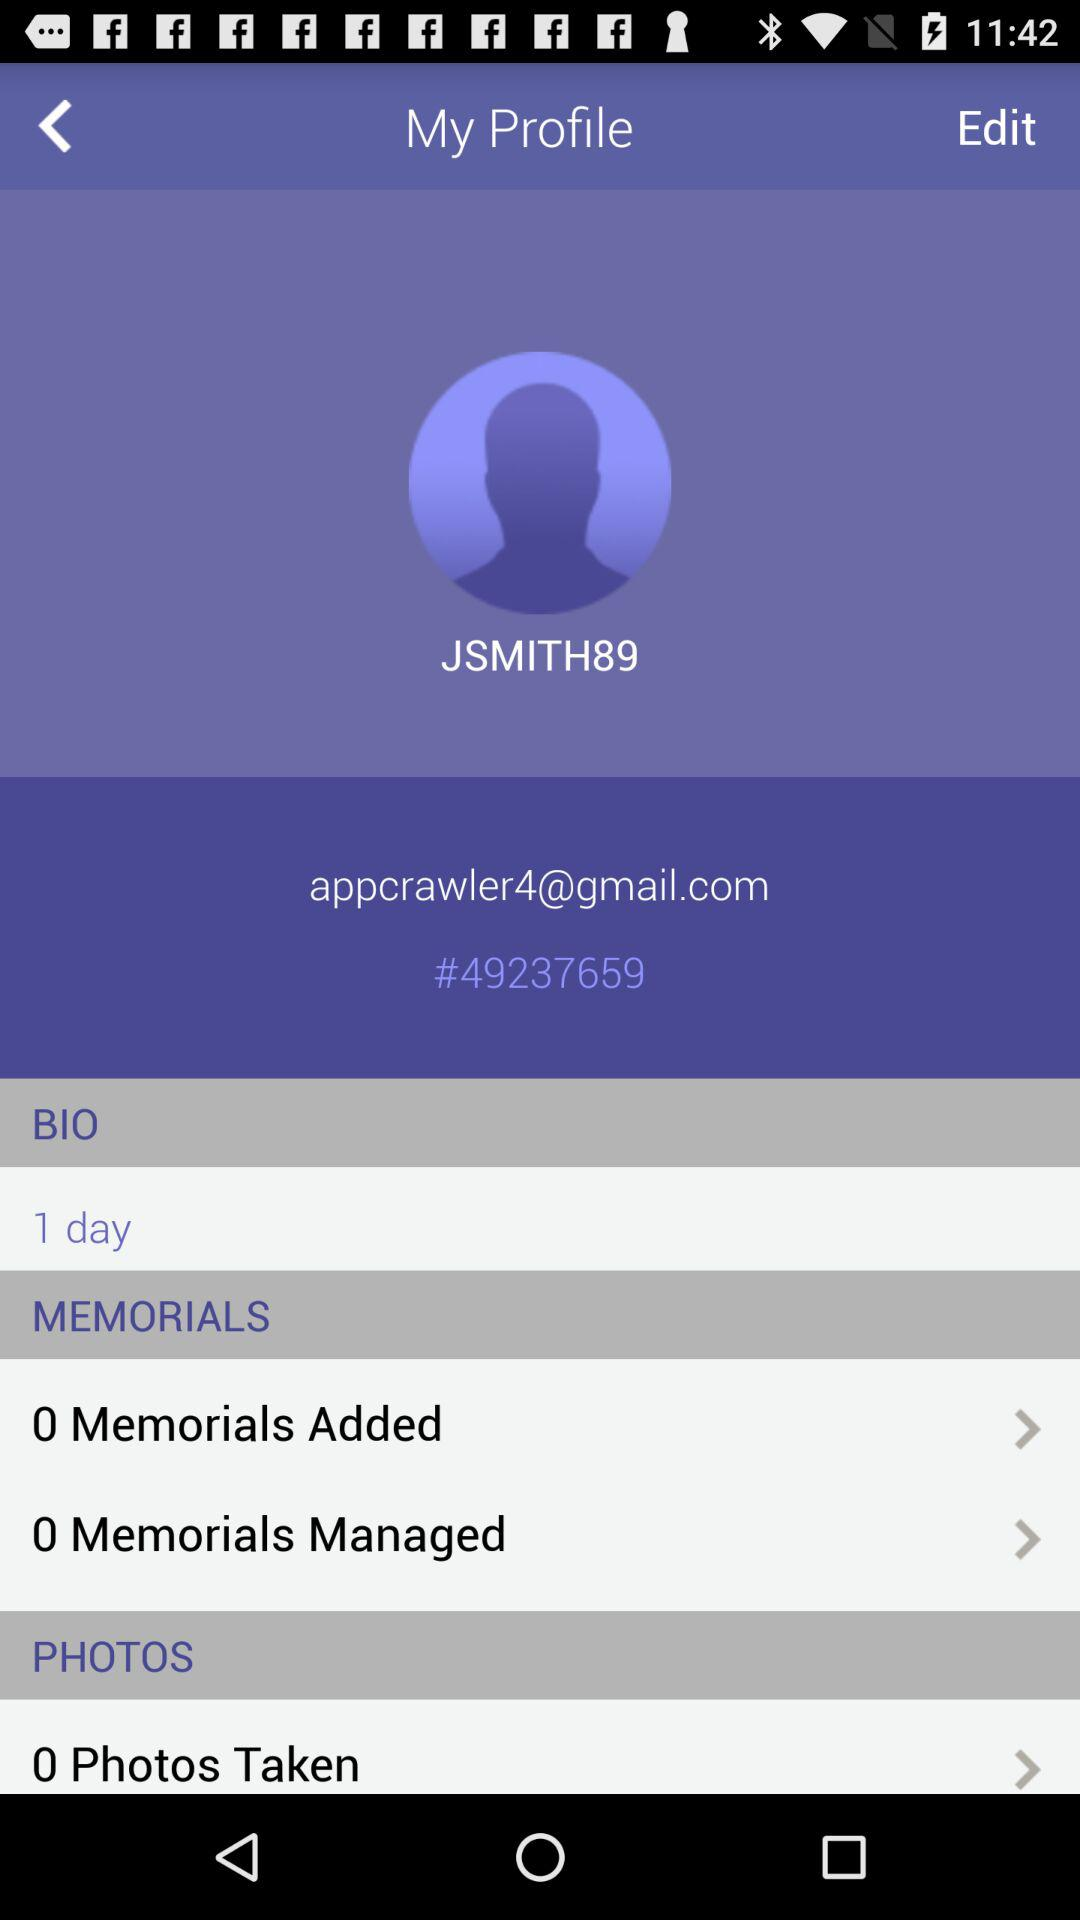How many days are shown? The number of shown days is 1. 